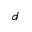Convert formula to latex. <formula><loc_0><loc_0><loc_500><loc_500>d</formula> 